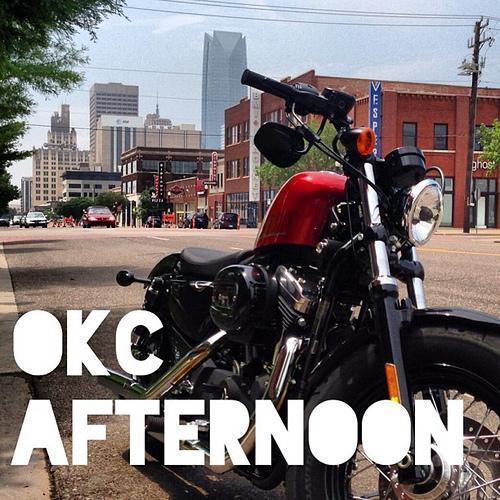How many motorcycles are in the photo?
Give a very brief answer. 1. 